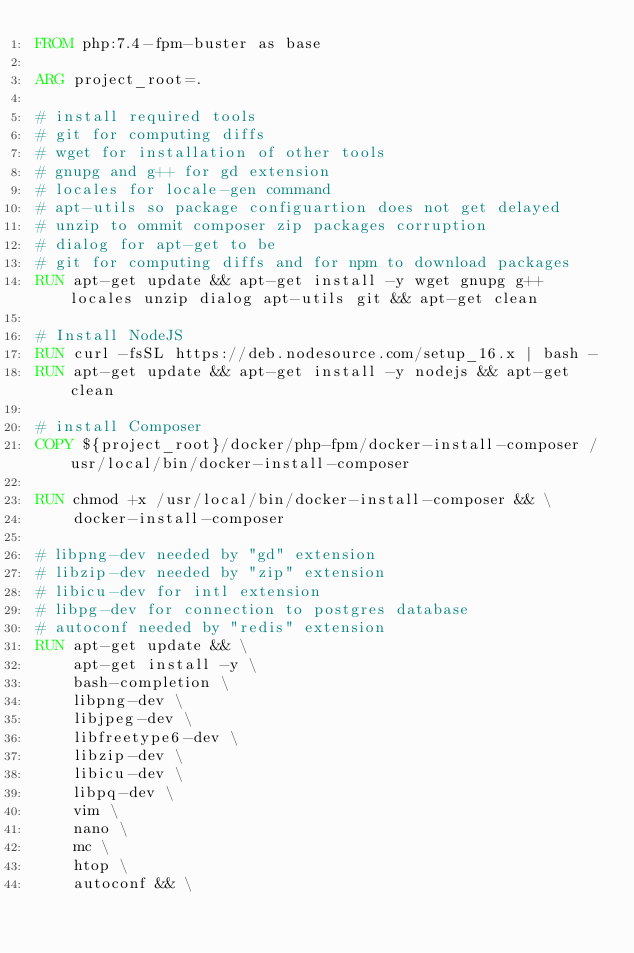Convert code to text. <code><loc_0><loc_0><loc_500><loc_500><_Dockerfile_>FROM php:7.4-fpm-buster as base

ARG project_root=.

# install required tools
# git for computing diffs
# wget for installation of other tools
# gnupg and g++ for gd extension
# locales for locale-gen command
# apt-utils so package configuartion does not get delayed
# unzip to ommit composer zip packages corruption
# dialog for apt-get to be
# git for computing diffs and for npm to download packages
RUN apt-get update && apt-get install -y wget gnupg g++ locales unzip dialog apt-utils git && apt-get clean

# Install NodeJS
RUN curl -fsSL https://deb.nodesource.com/setup_16.x | bash -
RUN apt-get update && apt-get install -y nodejs && apt-get clean

# install Composer
COPY ${project_root}/docker/php-fpm/docker-install-composer /usr/local/bin/docker-install-composer

RUN chmod +x /usr/local/bin/docker-install-composer && \
    docker-install-composer

# libpng-dev needed by "gd" extension
# libzip-dev needed by "zip" extension
# libicu-dev for intl extension
# libpg-dev for connection to postgres database
# autoconf needed by "redis" extension
RUN apt-get update && \
    apt-get install -y \
    bash-completion \
    libpng-dev \
    libjpeg-dev \
    libfreetype6-dev \
    libzip-dev \
    libicu-dev \
    libpq-dev \
    vim \
    nano \
    mc \
    htop \
    autoconf && \</code> 